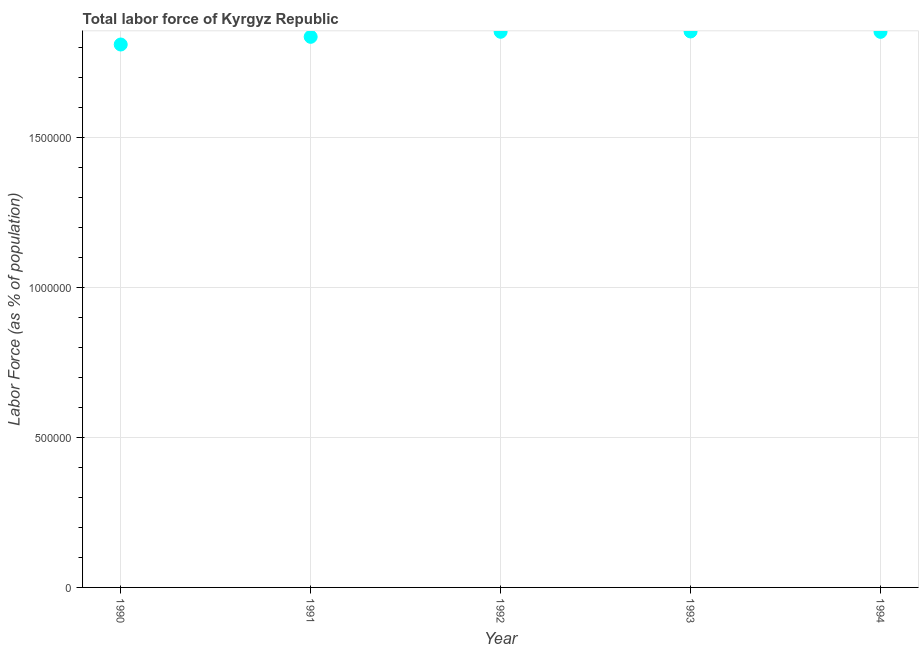What is the total labor force in 1994?
Your answer should be very brief. 1.85e+06. Across all years, what is the maximum total labor force?
Your response must be concise. 1.85e+06. Across all years, what is the minimum total labor force?
Offer a very short reply. 1.81e+06. What is the sum of the total labor force?
Provide a short and direct response. 9.20e+06. What is the difference between the total labor force in 1990 and 1992?
Give a very brief answer. -4.24e+04. What is the average total labor force per year?
Provide a succinct answer. 1.84e+06. What is the median total labor force?
Keep it short and to the point. 1.85e+06. In how many years, is the total labor force greater than 500000 %?
Keep it short and to the point. 5. Do a majority of the years between 1993 and 1992 (inclusive) have total labor force greater than 1000000 %?
Ensure brevity in your answer.  No. What is the ratio of the total labor force in 1990 to that in 1994?
Give a very brief answer. 0.98. Is the total labor force in 1993 less than that in 1994?
Offer a very short reply. No. What is the difference between the highest and the second highest total labor force?
Provide a succinct answer. 1016. Is the sum of the total labor force in 1990 and 1993 greater than the maximum total labor force across all years?
Ensure brevity in your answer.  Yes. What is the difference between the highest and the lowest total labor force?
Give a very brief answer. 4.34e+04. In how many years, is the total labor force greater than the average total labor force taken over all years?
Provide a short and direct response. 3. How many years are there in the graph?
Provide a succinct answer. 5. What is the difference between two consecutive major ticks on the Y-axis?
Your answer should be very brief. 5.00e+05. Are the values on the major ticks of Y-axis written in scientific E-notation?
Make the answer very short. No. Does the graph contain grids?
Your answer should be compact. Yes. What is the title of the graph?
Your response must be concise. Total labor force of Kyrgyz Republic. What is the label or title of the X-axis?
Provide a short and direct response. Year. What is the label or title of the Y-axis?
Your response must be concise. Labor Force (as % of population). What is the Labor Force (as % of population) in 1990?
Your response must be concise. 1.81e+06. What is the Labor Force (as % of population) in 1991?
Your answer should be very brief. 1.83e+06. What is the Labor Force (as % of population) in 1992?
Make the answer very short. 1.85e+06. What is the Labor Force (as % of population) in 1993?
Your answer should be compact. 1.85e+06. What is the Labor Force (as % of population) in 1994?
Your answer should be very brief. 1.85e+06. What is the difference between the Labor Force (as % of population) in 1990 and 1991?
Make the answer very short. -2.56e+04. What is the difference between the Labor Force (as % of population) in 1990 and 1992?
Give a very brief answer. -4.24e+04. What is the difference between the Labor Force (as % of population) in 1990 and 1993?
Your answer should be very brief. -4.34e+04. What is the difference between the Labor Force (as % of population) in 1990 and 1994?
Provide a succinct answer. -4.21e+04. What is the difference between the Labor Force (as % of population) in 1991 and 1992?
Give a very brief answer. -1.68e+04. What is the difference between the Labor Force (as % of population) in 1991 and 1993?
Your answer should be very brief. -1.78e+04. What is the difference between the Labor Force (as % of population) in 1991 and 1994?
Provide a short and direct response. -1.65e+04. What is the difference between the Labor Force (as % of population) in 1992 and 1993?
Give a very brief answer. -1016. What is the difference between the Labor Force (as % of population) in 1992 and 1994?
Your answer should be very brief. 282. What is the difference between the Labor Force (as % of population) in 1993 and 1994?
Provide a short and direct response. 1298. What is the ratio of the Labor Force (as % of population) in 1990 to that in 1991?
Give a very brief answer. 0.99. What is the ratio of the Labor Force (as % of population) in 1990 to that in 1992?
Your answer should be compact. 0.98. What is the ratio of the Labor Force (as % of population) in 1990 to that in 1993?
Your response must be concise. 0.98. What is the ratio of the Labor Force (as % of population) in 1990 to that in 1994?
Make the answer very short. 0.98. What is the ratio of the Labor Force (as % of population) in 1992 to that in 1994?
Give a very brief answer. 1. 